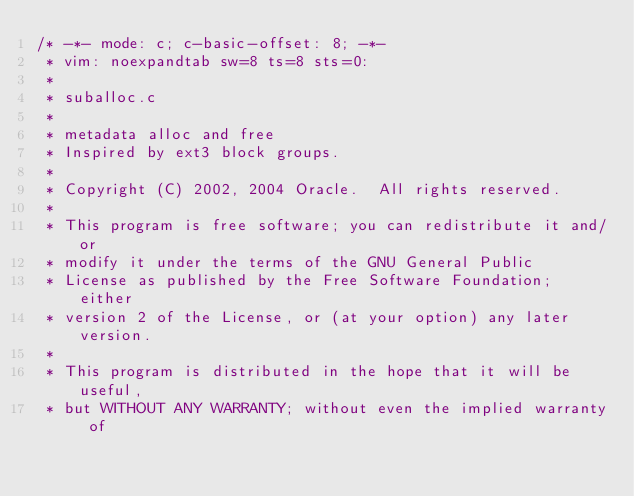Convert code to text. <code><loc_0><loc_0><loc_500><loc_500><_C_>/* -*- mode: c; c-basic-offset: 8; -*-
 * vim: noexpandtab sw=8 ts=8 sts=0:
 *
 * suballoc.c
 *
 * metadata alloc and free
 * Inspired by ext3 block groups.
 *
 * Copyright (C) 2002, 2004 Oracle.  All rights reserved.
 *
 * This program is free software; you can redistribute it and/or
 * modify it under the terms of the GNU General Public
 * License as published by the Free Software Foundation; either
 * version 2 of the License, or (at your option) any later version.
 *
 * This program is distributed in the hope that it will be useful,
 * but WITHOUT ANY WARRANTY; without even the implied warranty of</code> 